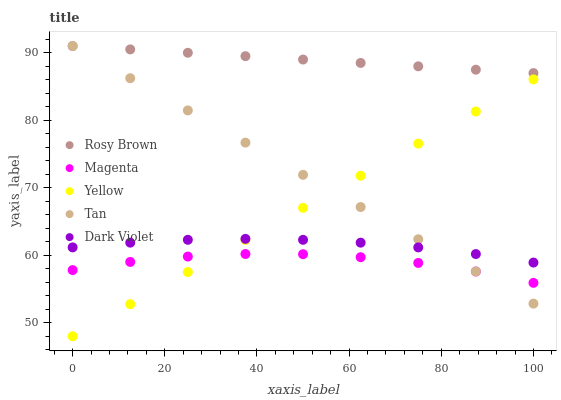Does Magenta have the minimum area under the curve?
Answer yes or no. Yes. Does Rosy Brown have the maximum area under the curve?
Answer yes or no. Yes. Does Dark Violet have the minimum area under the curve?
Answer yes or no. No. Does Dark Violet have the maximum area under the curve?
Answer yes or no. No. Is Rosy Brown the smoothest?
Answer yes or no. Yes. Is Magenta the roughest?
Answer yes or no. Yes. Is Dark Violet the smoothest?
Answer yes or no. No. Is Dark Violet the roughest?
Answer yes or no. No. Does Yellow have the lowest value?
Answer yes or no. Yes. Does Dark Violet have the lowest value?
Answer yes or no. No. Does Tan have the highest value?
Answer yes or no. Yes. Does Dark Violet have the highest value?
Answer yes or no. No. Is Magenta less than Dark Violet?
Answer yes or no. Yes. Is Rosy Brown greater than Yellow?
Answer yes or no. Yes. Does Tan intersect Magenta?
Answer yes or no. Yes. Is Tan less than Magenta?
Answer yes or no. No. Is Tan greater than Magenta?
Answer yes or no. No. Does Magenta intersect Dark Violet?
Answer yes or no. No. 